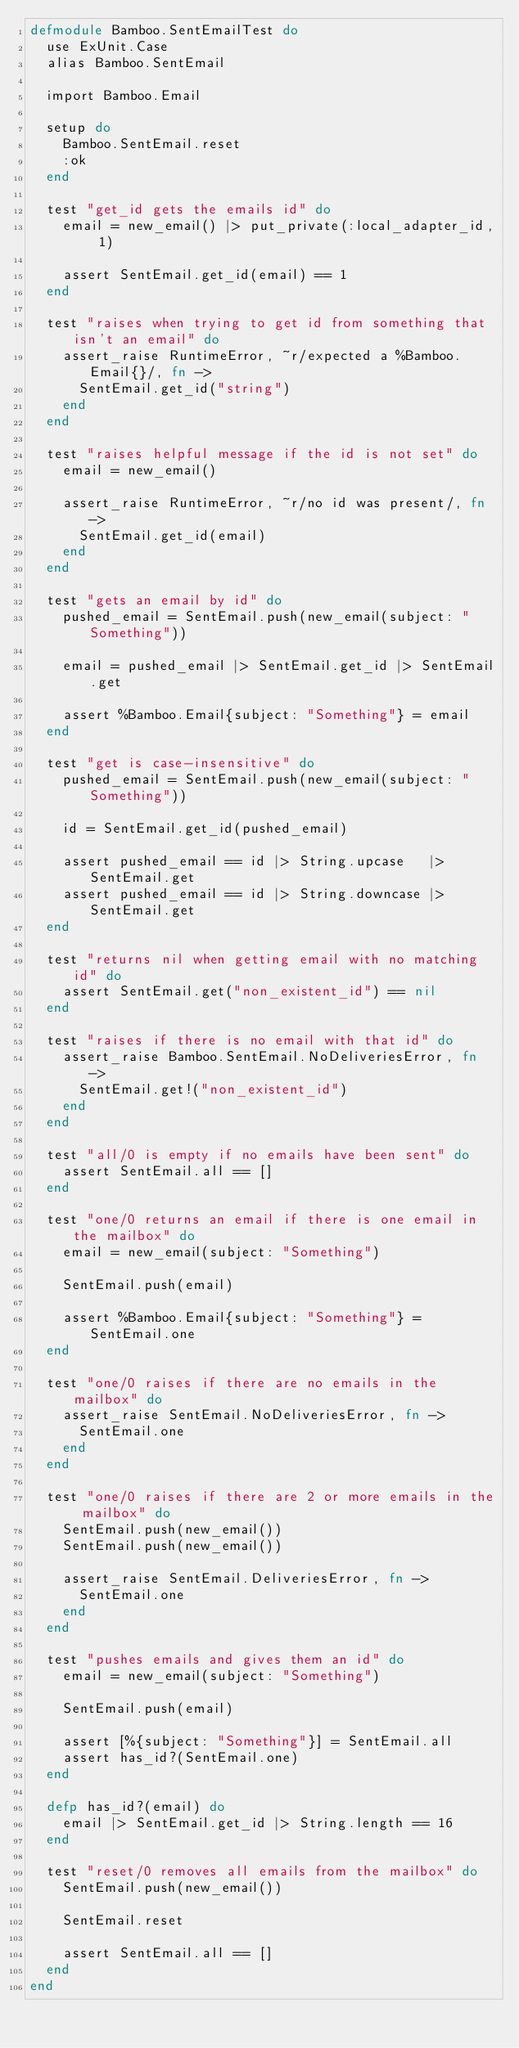<code> <loc_0><loc_0><loc_500><loc_500><_Elixir_>defmodule Bamboo.SentEmailTest do
  use ExUnit.Case
  alias Bamboo.SentEmail

  import Bamboo.Email

  setup do
    Bamboo.SentEmail.reset
    :ok
  end

  test "get_id gets the emails id" do
    email = new_email() |> put_private(:local_adapter_id, 1)

    assert SentEmail.get_id(email) == 1
  end

  test "raises when trying to get id from something that isn't an email" do
    assert_raise RuntimeError, ~r/expected a %Bamboo.Email{}/, fn ->
      SentEmail.get_id("string")
    end
  end

  test "raises helpful message if the id is not set" do
    email = new_email()

    assert_raise RuntimeError, ~r/no id was present/, fn ->
      SentEmail.get_id(email)
    end
  end

  test "gets an email by id" do
    pushed_email = SentEmail.push(new_email(subject: "Something"))

    email = pushed_email |> SentEmail.get_id |> SentEmail.get

    assert %Bamboo.Email{subject: "Something"} = email
  end

  test "get is case-insensitive" do
    pushed_email = SentEmail.push(new_email(subject: "Something"))

    id = SentEmail.get_id(pushed_email)

    assert pushed_email == id |> String.upcase   |> SentEmail.get
    assert pushed_email == id |> String.downcase |> SentEmail.get
  end

  test "returns nil when getting email with no matching id" do
    assert SentEmail.get("non_existent_id") == nil
  end

  test "raises if there is no email with that id" do
    assert_raise Bamboo.SentEmail.NoDeliveriesError, fn ->
      SentEmail.get!("non_existent_id")
    end
  end

  test "all/0 is empty if no emails have been sent" do
    assert SentEmail.all == []
  end

  test "one/0 returns an email if there is one email in the mailbox" do
    email = new_email(subject: "Something")

    SentEmail.push(email)

    assert %Bamboo.Email{subject: "Something"} = SentEmail.one
  end

  test "one/0 raises if there are no emails in the mailbox" do
    assert_raise SentEmail.NoDeliveriesError, fn ->
      SentEmail.one
    end
  end

  test "one/0 raises if there are 2 or more emails in the mailbox" do
    SentEmail.push(new_email())
    SentEmail.push(new_email())

    assert_raise SentEmail.DeliveriesError, fn ->
      SentEmail.one
    end
  end

  test "pushes emails and gives them an id" do
    email = new_email(subject: "Something")

    SentEmail.push(email)

    assert [%{subject: "Something"}] = SentEmail.all
    assert has_id?(SentEmail.one)
  end

  defp has_id?(email) do
    email |> SentEmail.get_id |> String.length == 16
  end

  test "reset/0 removes all emails from the mailbox" do
    SentEmail.push(new_email())

    SentEmail.reset

    assert SentEmail.all == []
  end
end
</code> 